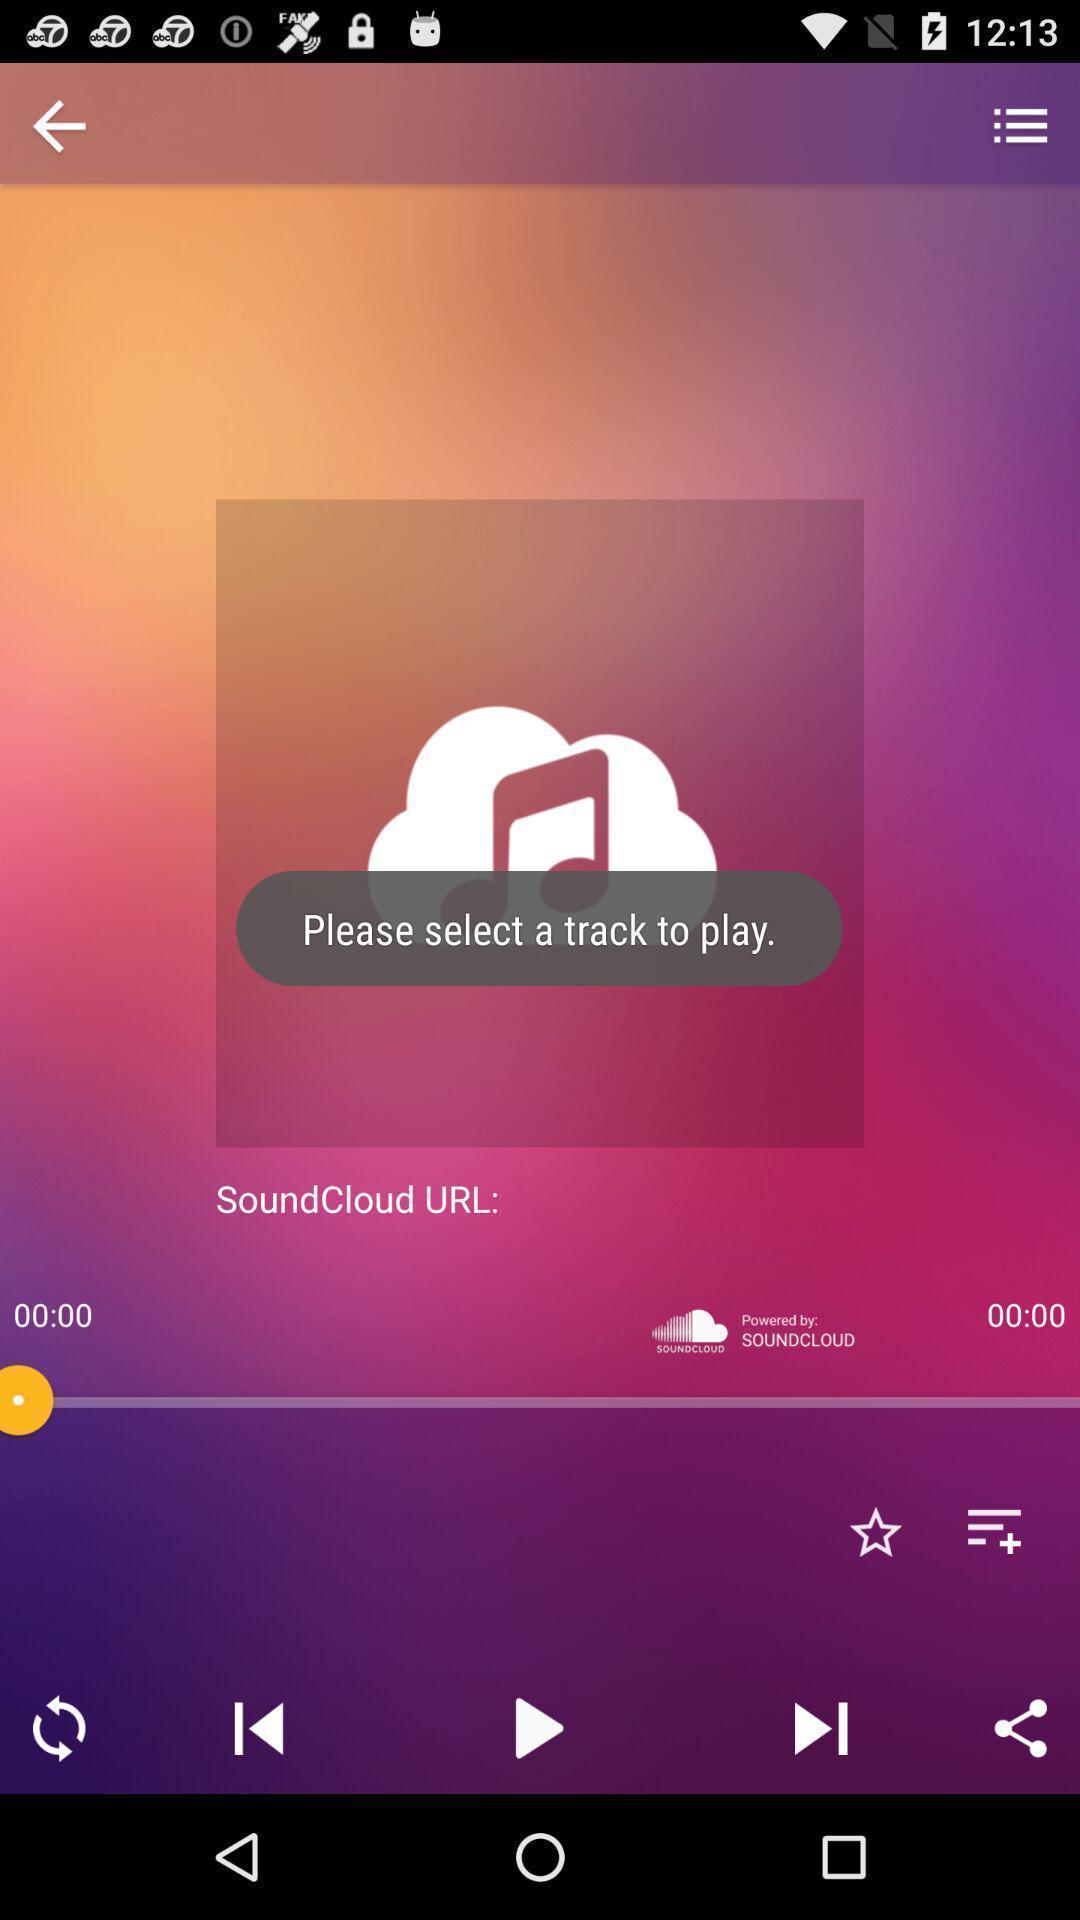Provide a description of this screenshot. Select a track to play in music player. 